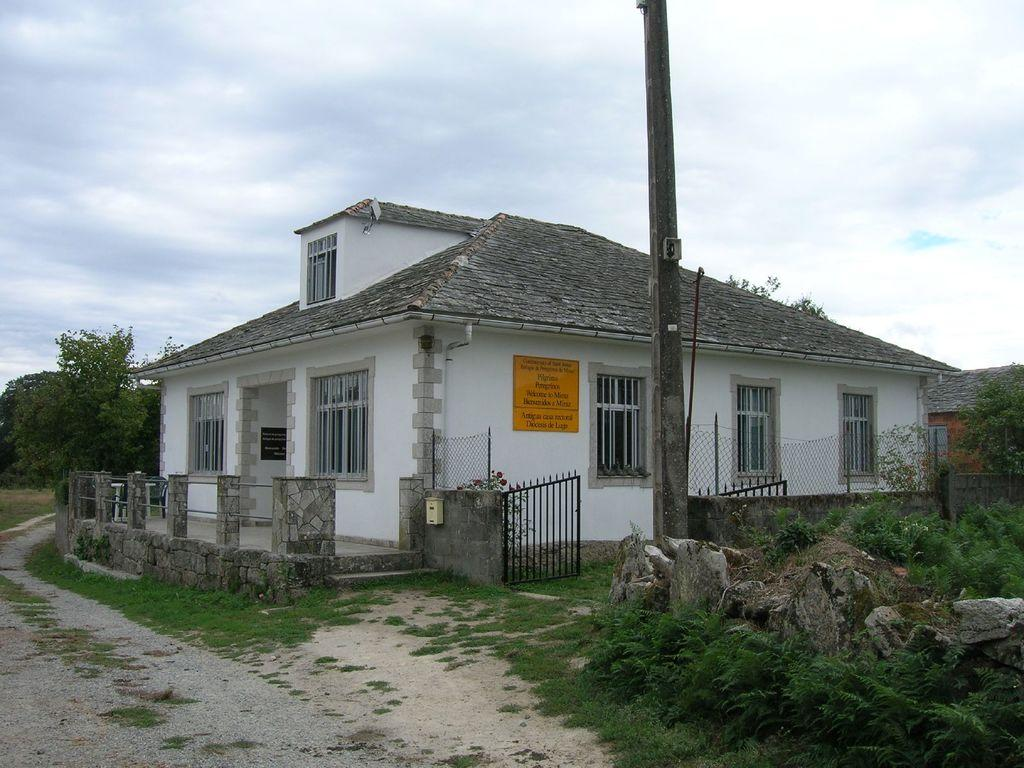What type of structures can be seen in the image? There are houses in the image. What natural elements are present in the image? There are trees, grass, and stones in the image. What architectural features can be observed in the image? There are windows, a pole, a gate, and a wall in the image. What additional objects are present in the image? There are boards with text in the image. What type of hammer is being used to hit the pot in the image? There is no hammer or pot present in the image. What kind of lumber is being used to build the structure in the image? There is no lumber or structure being built in the image. 